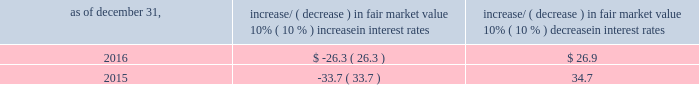Item 7a .
Quantitative and qualitative disclosures about market risk ( amounts in millions ) in the normal course of business , we are exposed to market risks related to interest rates , foreign currency rates and certain balance sheet items .
From time to time , we use derivative instruments , pursuant to established guidelines and policies , to manage some portion of these risks .
Derivative instruments utilized in our hedging activities are viewed as risk management tools and are not used for trading or speculative purposes .
Interest rates our exposure to market risk for changes in interest rates relates primarily to the fair market value and cash flows of our debt obligations .
The majority of our debt ( approximately 93% ( 93 % ) and 89% ( 89 % ) as of december 31 , 2016 and 2015 , respectively ) bears interest at fixed rates .
We do have debt with variable interest rates , but a 10% ( 10 % ) increase or decrease in interest rates would not be material to our interest expense or cash flows .
The fair market value of our debt is sensitive to changes in interest rates , and the impact of a 10% ( 10 % ) change in interest rates is summarized below .
Increase/ ( decrease ) in fair market value as of december 31 , 10% ( 10 % ) increase in interest rates 10% ( 10 % ) decrease in interest rates .
We have used interest rate swaps for risk management purposes to manage our exposure to changes in interest rates .
We do not have any interest rate swaps outstanding as of december 31 , 2016 .
We had $ 1100.6 of cash , cash equivalents and marketable securities as of december 31 , 2016 that we generally invest in conservative , short-term bank deposits or securities .
The interest income generated from these investments is subject to both domestic and foreign interest rate movements .
During 2016 and 2015 , we had interest income of $ 20.1 and $ 22.8 , respectively .
Based on our 2016 results , a 100 basis-point increase or decrease in interest rates would affect our interest income by approximately $ 11.0 , assuming that all cash , cash equivalents and marketable securities are impacted in the same manner and balances remain constant from year-end 2016 levels .
Foreign currency rates we are subject to translation and transaction risks related to changes in foreign currency exchange rates .
Since we report revenues and expenses in u.s .
Dollars , changes in exchange rates may either positively or negatively affect our consolidated revenues and expenses ( as expressed in u.s .
Dollars ) from foreign operations .
The foreign currencies that most impacted our results during 2016 included the british pound sterling and , to a lesser extent , the argentine peso , brazilian real and japanese yen .
Based on 2016 exchange rates and operating results , if the u.s .
Dollar were to strengthen or weaken by 10% ( 10 % ) , we currently estimate operating income would decrease or increase approximately 4% ( 4 % ) , assuming that all currencies are impacted in the same manner and our international revenue and expenses remain constant at 2016 levels .
The functional currency of our foreign operations is generally their respective local currency .
Assets and liabilities are translated at the exchange rates in effect at the balance sheet date , and revenues and expenses are translated at the average exchange rates during the period presented .
The resulting translation adjustments are recorded as a component of accumulated other comprehensive loss , net of tax , in the stockholders 2019 equity section of our consolidated balance sheets .
Our foreign subsidiaries generally collect revenues and pay expenses in their functional currency , mitigating transaction risk .
However , certain subsidiaries may enter into transactions in currencies other than their functional currency .
Assets and liabilities denominated in currencies other than the functional currency are susceptible to movements in foreign currency until final settlement .
Currency transaction gains or losses primarily arising from transactions in currencies other than the functional currency are included in office and general expenses .
We regularly review our foreign exchange exposures that may have a material impact on our business and from time to time use foreign currency forward exchange contracts or other derivative financial instruments to hedge the effects of potential adverse fluctuations in foreign currency exchange rates arising from these exposures .
We do not enter into foreign exchange contracts or other derivatives for speculative purposes. .
What is the difference in the debt fair market value between 2015 and 2016 if the market interest rate decreases by 10%? 
Computations: (34.7 - 26.9)
Answer: 7.8. 